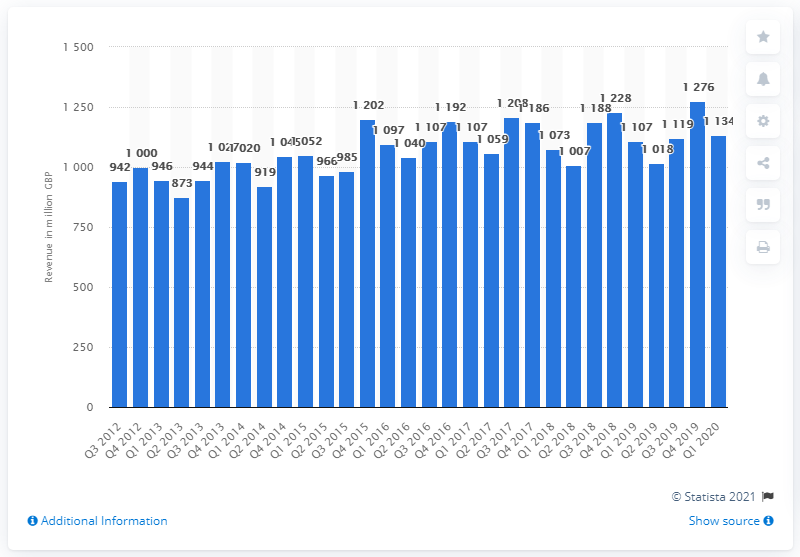Give some essential details in this illustration. The revenue from domestic appliances in the UK in the first quarter of 2020 was 1134. In the first quarter of 2019, the revenue of domestic appliances was 1107. 